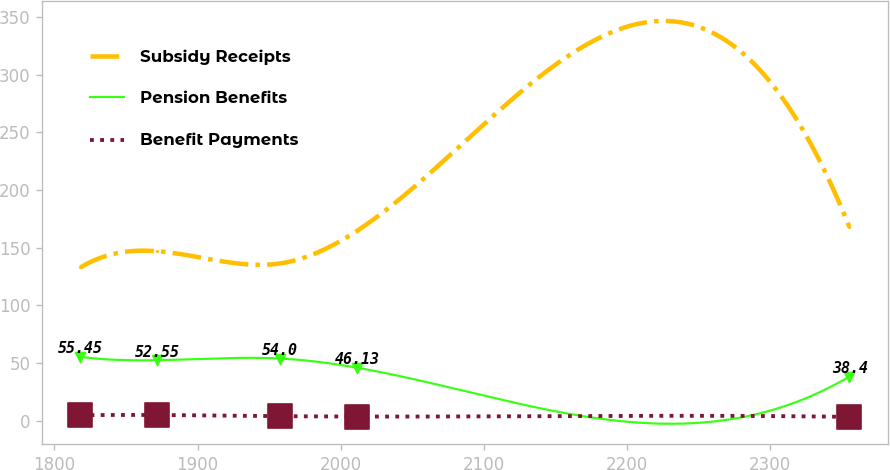<chart> <loc_0><loc_0><loc_500><loc_500><line_chart><ecel><fcel>Subsidy Receipts<fcel>Pension Benefits<fcel>Benefit Payments<nl><fcel>1818.11<fcel>132.91<fcel>55.45<fcel>4.89<nl><fcel>1871.85<fcel>147<fcel>52.55<fcel>5.05<nl><fcel>1957.49<fcel>136.38<fcel>54<fcel>4.07<nl><fcel>2011.23<fcel>164.48<fcel>46.13<fcel>3.74<nl><fcel>2355.53<fcel>167.95<fcel>38.4<fcel>3.44<nl></chart> 